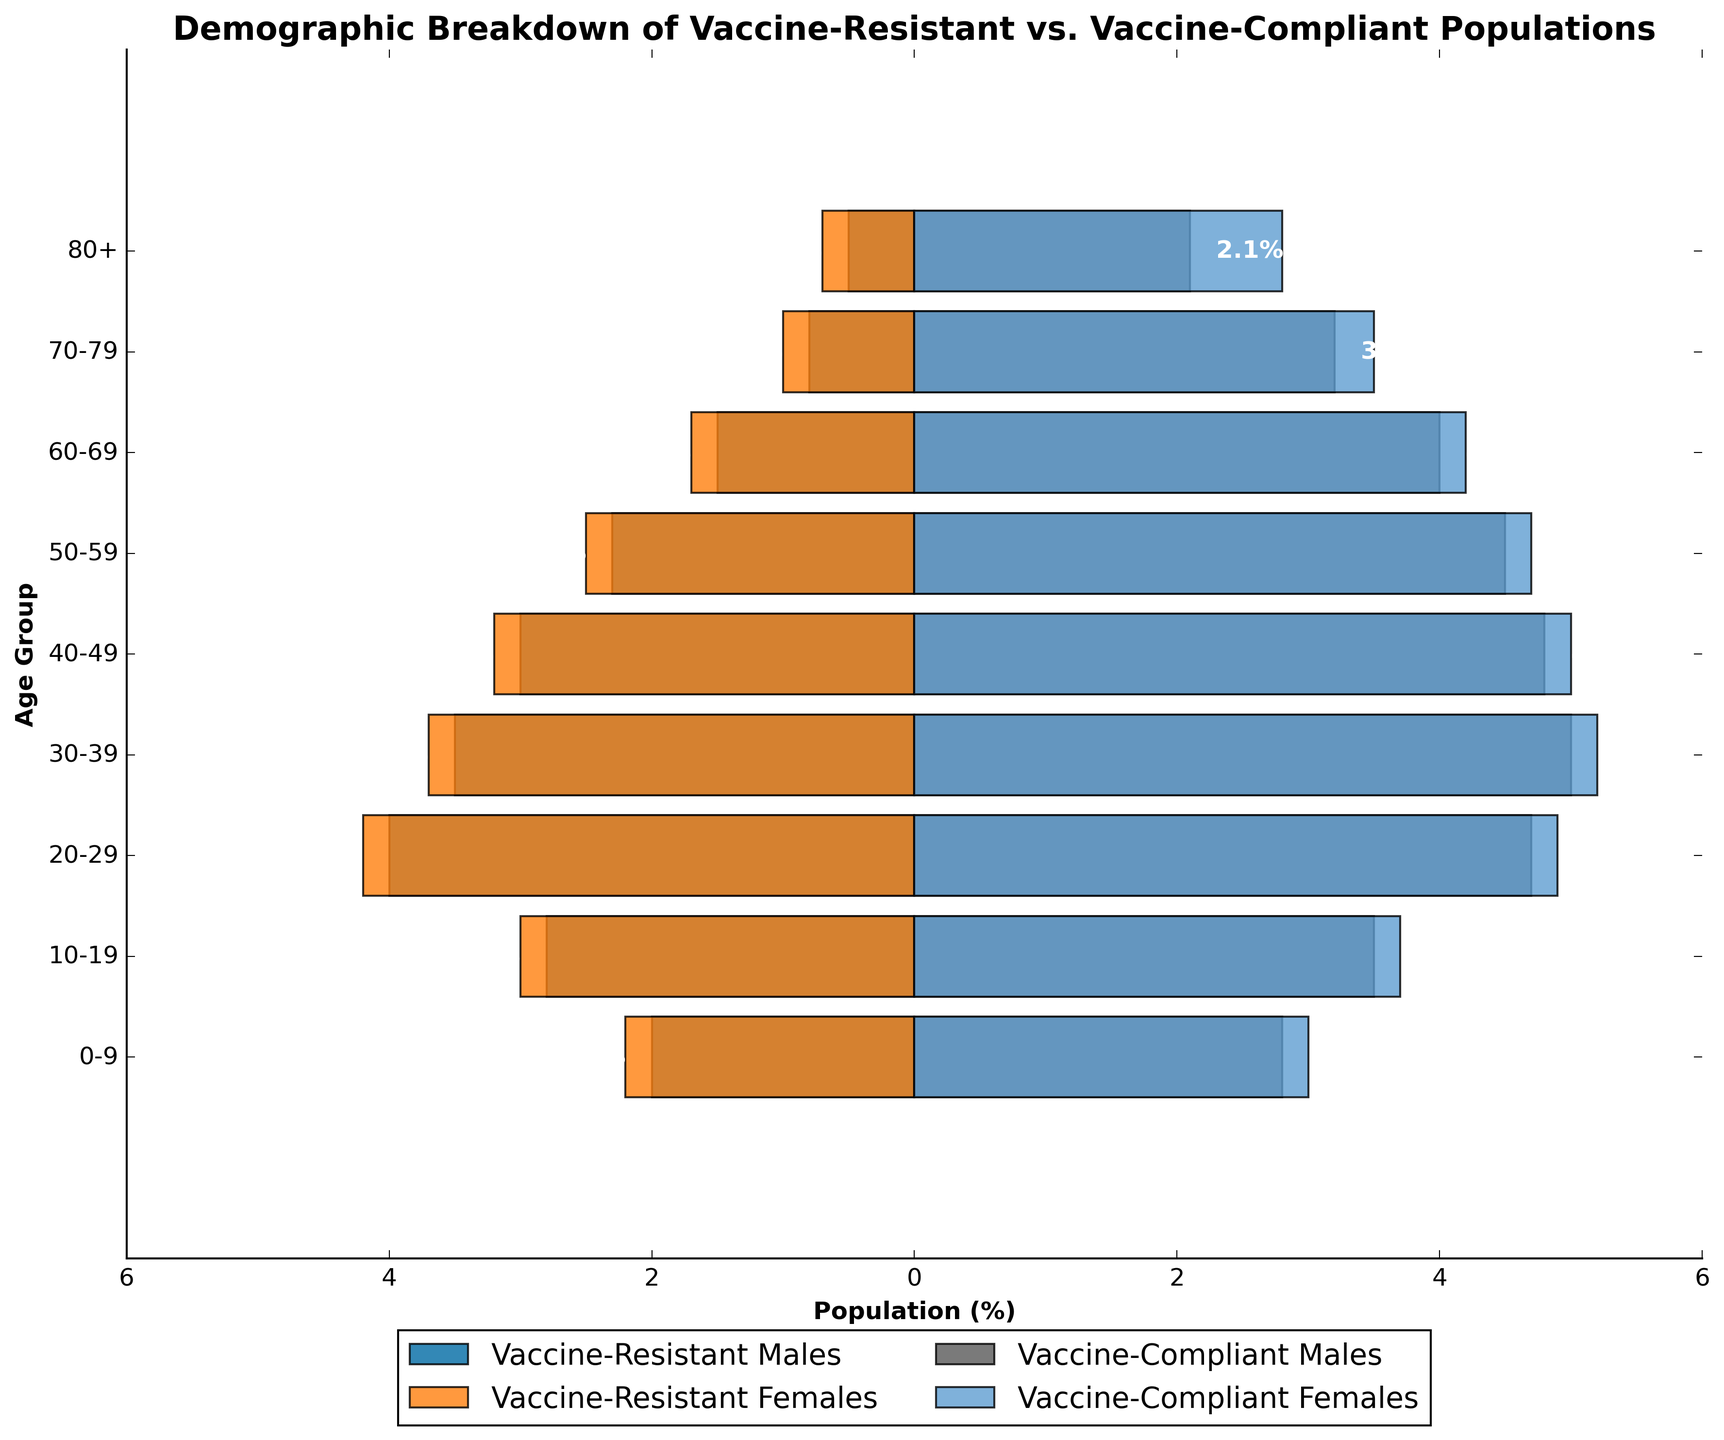What is the population percentage of vaccine-resistant males in the 20-29 age group? Look at the bar corresponding to "20-29" on the y-axis and find the length of the bar for vaccine-resistant males. It extends to -4.0%.
Answer: 4.0% How does the population of vaccine-compliant females in the 80+ age group compare to that of vaccine-compliant males in the same age group? Compare the lengths of the bars for vaccine-compliant females and vaccine-compliant males in the 80+ age group. The bar for females extends to 2.8% while the bar for males extends to 2.1%.
Answer: Vaccine-compliant females have a higher percentage (2.8% vs. 2.1%) Which age group has the highest percentage of vaccine-compliant individuals? Sum the percentages of vaccine-compliant males and females for each age group and find the highest. 30-39 has 5.0% (males) + 5.2% (females) = 10.2%, which is the highest.
Answer: 30-39 What is the total population percentage of vaccine-resistant individuals in the 40-49 age group? Sum the percentages of vaccine-resistant males and females for the 40-49 age group. The value for males is 3.0% and for females is 3.2%, so 3.0% + 3.2% = 6.2%.
Answer: 6.2% Compare the vaccine resistance between males and females in the 60-69 age group. Look at the lengths of the bars for vaccine-resistant males and females in the 60-69 age group. The bar for males extends to -1.5%, and the bar for females extends to -1.7%.
Answer: Females have a higher vaccine resistance (-1.7% vs. -1.5%) Which gender shows higher vaccine resistance in the 50-59 age group? Compare the lengths of the vaccine-resistant male and female bars in the 50-59 age group. The bar for females extends to -2.5%, and the bar for males extends to -2.3%.
Answer: Females How does the population percentage of vaccine-compliant individuals in the 70-79 age group compare to that in the 80+ age group? Add the percentages of vaccine-compliant males and females for each group. For 70-79, it is 3.2% (males) + 3.5% (females) = 6.7%. For 80+, it is 2.1% (males) + 2.8% (females) = 4.9%. Compare the two sums.
Answer: 70-79 has a higher percentage (6.7% vs. 4.9%) What age group has the lowest percentage of vaccine-resistant females? Check the lengths of the bars for vaccine-resistant females across all age groups and identify the smallest bar in magnitude. The smallest value appears for the 80+ age group at -0.7%.
Answer: 80+ What is the combined percentage of vaccine-compliant males and females in the 20-29 age group? Add the percentages of vaccine-compliant males and females for the 20-29 age group. The values are 4.7% (males) and 4.9% (females), so 4.7% + 4.9% = 9.6%.
Answer: 9.6% 